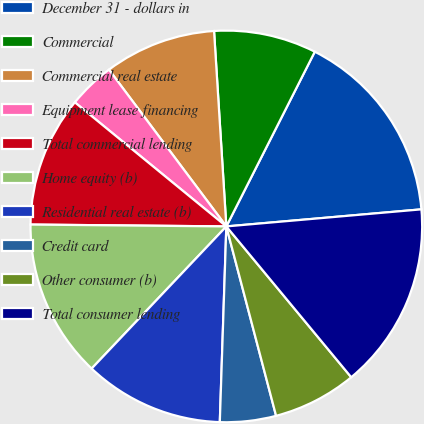Convert chart. <chart><loc_0><loc_0><loc_500><loc_500><pie_chart><fcel>December 31 - dollars in<fcel>Commercial<fcel>Commercial real estate<fcel>Equipment lease financing<fcel>Total commercial lending<fcel>Home equity (b)<fcel>Residential real estate (b)<fcel>Credit card<fcel>Other consumer (b)<fcel>Total consumer lending<nl><fcel>16.15%<fcel>8.46%<fcel>9.23%<fcel>3.85%<fcel>10.77%<fcel>13.08%<fcel>11.54%<fcel>4.62%<fcel>6.92%<fcel>15.38%<nl></chart> 